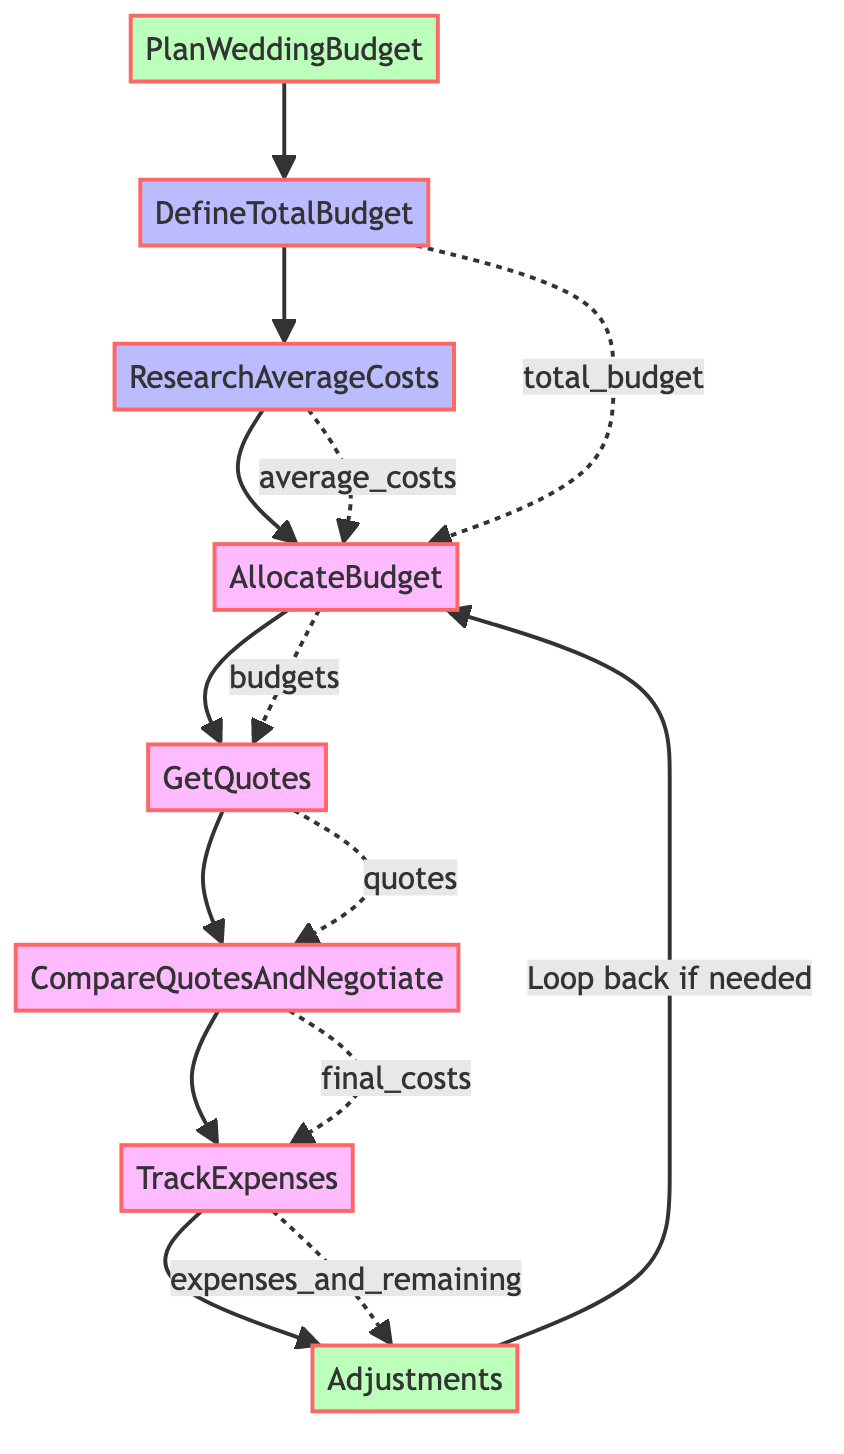What's the first step in planning the wedding budget? The first step indicated in the diagram is "DefineTotalBudget", which involves determining the overall amount of money available for the wedding.
Answer: DefineTotalBudget How many steps are there in the wedding budget planning flowchart? The diagram lists a total of 7 steps involved in the planning process that follow the initial step of defining the total budget.
Answer: 7 What does the "AllocateBudget" step entail? The "AllocateBudget" step involves distributing portions of the total budget to key areas such as venue, catering, attire, and more.
Answer: Allocate portions of the total budget to key areas Which step comes after "GetQuotes"? Following "GetQuotes", the next step in the flowchart is "CompareQuotesAndNegotiate". This step involves analyzing the quotes obtained and negotiating for better prices.
Answer: CompareQuotesAndNegotiate What is the final step in the process? The final step in the process, as depicted in the diagram, is "Adjustments," which entails making necessary changes to the budget allocation based on actual expenses.
Answer: Adjustments How do quotes relate to the budget allocation? Quotes are obtained from vendors after allocating the budget. The "GetQuotes" step relies on the budget posted during the "AllocateBudget" step.
Answer: Quotes rely on the allocated budget What do you do if adjustments are needed? If adjustments are necessary as indicated in the diagram, one would loop back to the "AllocateBudget" step to make the required changes after reviewing expenses.
Answer: Loop back to AllocateBudget What is tracked in the "TrackExpenses" step? During the "TrackExpenses" step, the diagram specifies that one should keep track of total expenses and remaining budget to ensure financial management is maintained.
Answer: Keep track of total expenses and remaining budget 